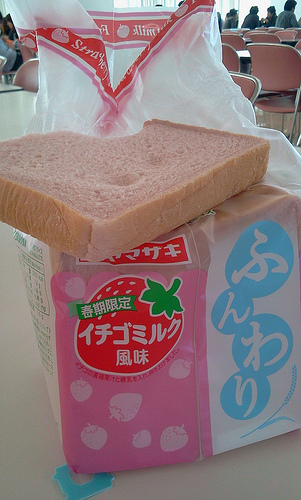<image>
Can you confirm if the bread is under the chair? No. The bread is not positioned under the chair. The vertical relationship between these objects is different. 